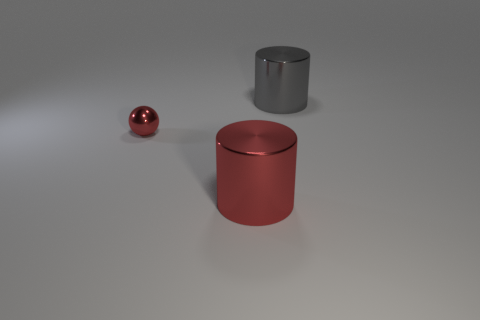Add 2 red metal cylinders. How many objects exist? 5 Subtract all cylinders. How many objects are left? 1 Subtract 0 blue cubes. How many objects are left? 3 Subtract all small yellow rubber blocks. Subtract all tiny metal things. How many objects are left? 2 Add 1 big metal cylinders. How many big metal cylinders are left? 3 Add 3 large blue cubes. How many large blue cubes exist? 3 